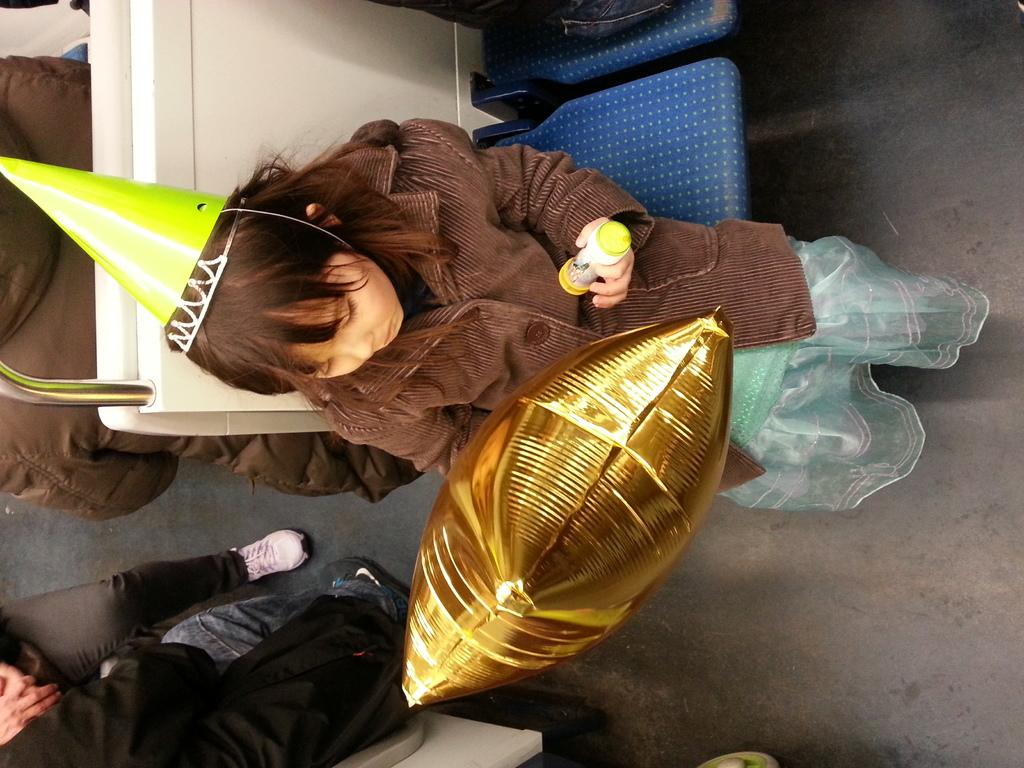What is the girl in the image holding? The girl is holding objects in the image. What is the girl's position in the image? The girl is sitting on a seat. Are there any other people in the image? Yes, there is another person sitting in the image. What can be seen of the two persons in the image? The legs of two persons are visible in the image. What type of fish is swimming near the girl in the image? There is no fish present in the image. Who is the manager of the girl in the image? There is no mention of a manager in the image or the provided facts. 